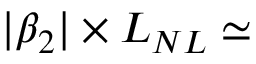Convert formula to latex. <formula><loc_0><loc_0><loc_500><loc_500>| \beta _ { 2 } | \times L _ { N L } \simeq</formula> 